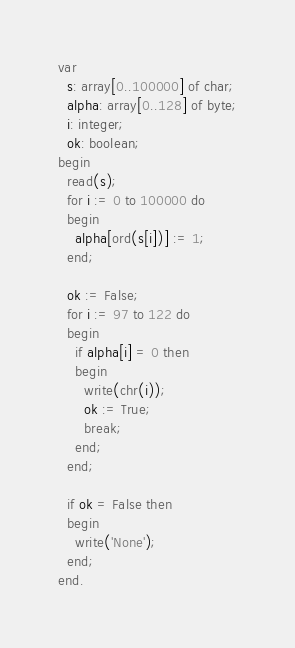<code> <loc_0><loc_0><loc_500><loc_500><_Pascal_>var
  s: array[0..100000] of char;
  alpha: array[0..128] of byte;
  i: integer;
  ok: boolean;
begin
  read(s);
  for i := 0 to 100000 do
  begin
    alpha[ord(s[i])] := 1;
  end;
  
  ok := False;
  for i := 97 to 122 do
  begin
    if alpha[i] = 0 then
    begin
      write(chr(i));
      ok := True;
      break;
    end;
  end;
  
  if ok = False then
  begin
    write('None');
  end;
end.</code> 